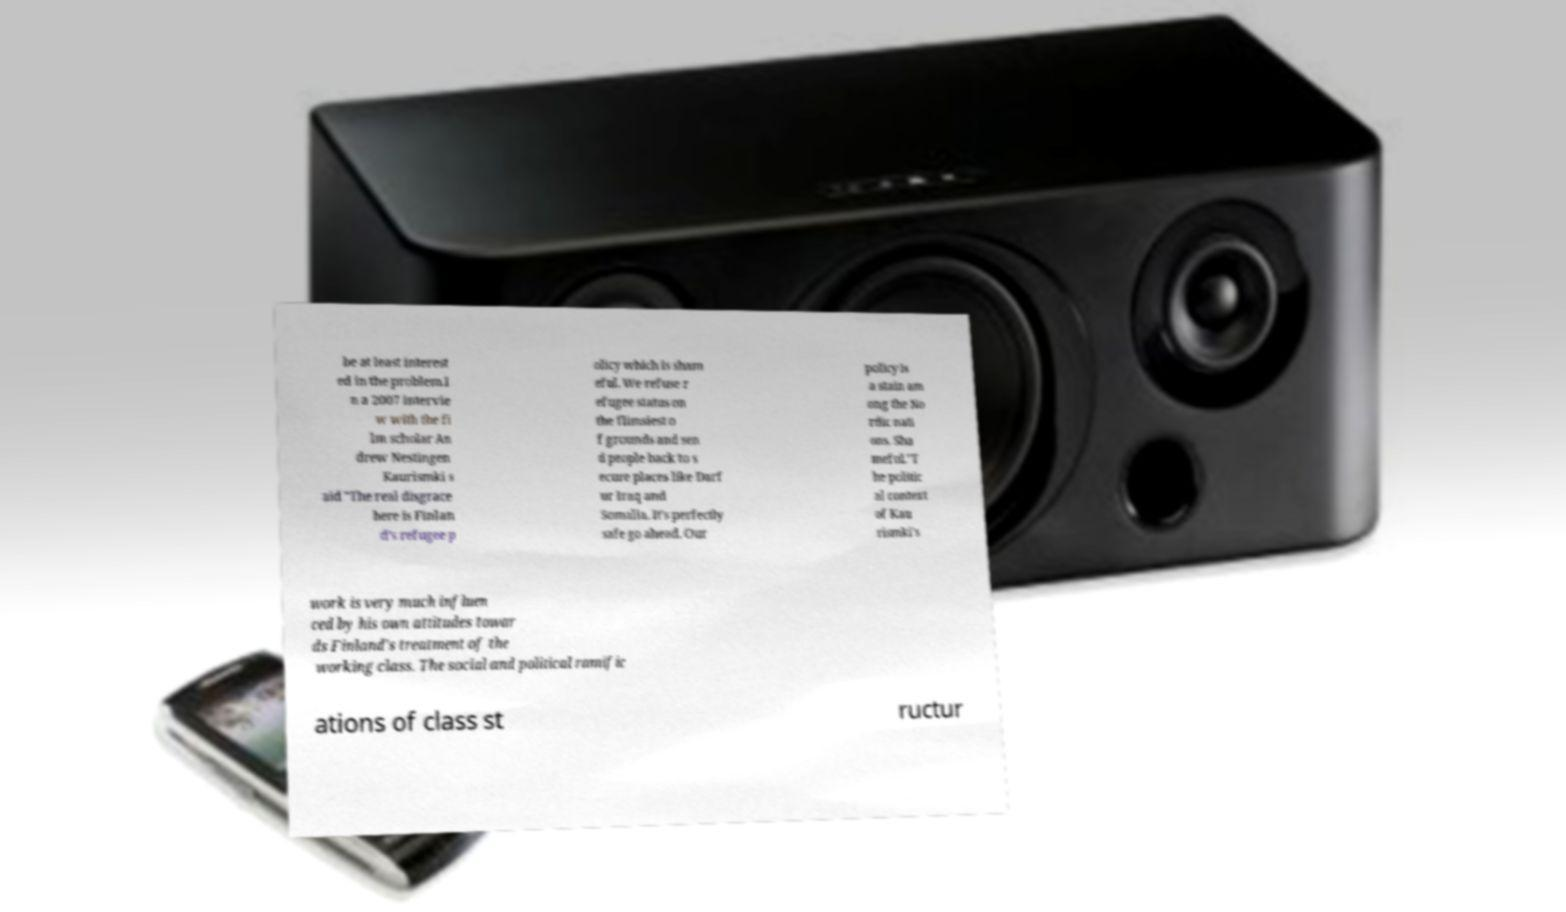Could you extract and type out the text from this image? be at least interest ed in the problem.I n a 2007 intervie w with the fi lm scholar An drew Nestingen Kaurismki s aid "The real disgrace here is Finlan d’s refugee p olicy which is sham eful. We refuse r efugee status on the flimsiest o f grounds and sen d people back to s ecure places like Darf ur Iraq and Somalia. It’s perfectly safe go ahead. Our policy is a stain am ong the No rdic nati ons. Sha meful."T he politic al context of Kau rismki's work is very much influen ced by his own attitudes towar ds Finland's treatment of the working class. The social and political ramific ations of class st ructur 